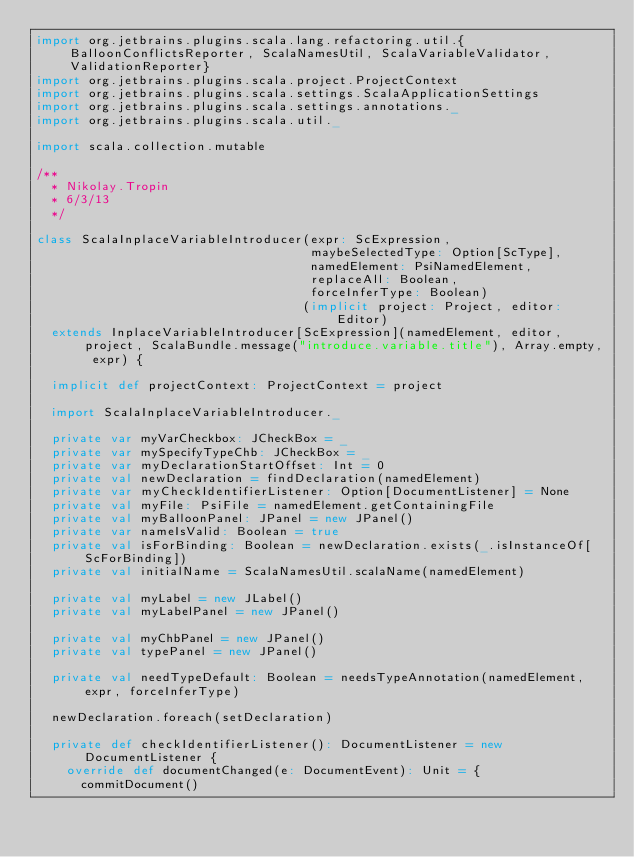Convert code to text. <code><loc_0><loc_0><loc_500><loc_500><_Scala_>import org.jetbrains.plugins.scala.lang.refactoring.util.{BalloonConflictsReporter, ScalaNamesUtil, ScalaVariableValidator, ValidationReporter}
import org.jetbrains.plugins.scala.project.ProjectContext
import org.jetbrains.plugins.scala.settings.ScalaApplicationSettings
import org.jetbrains.plugins.scala.settings.annotations._
import org.jetbrains.plugins.scala.util._

import scala.collection.mutable

/**
  * Nikolay.Tropin
  * 6/3/13
  */

class ScalaInplaceVariableIntroducer(expr: ScExpression,
                                     maybeSelectedType: Option[ScType],
                                     namedElement: PsiNamedElement,
                                     replaceAll: Boolean,
                                     forceInferType: Boolean)
                                    (implicit project: Project, editor: Editor)
  extends InplaceVariableIntroducer[ScExpression](namedElement, editor, project, ScalaBundle.message("introduce.variable.title"), Array.empty, expr) {

  implicit def projectContext: ProjectContext = project

  import ScalaInplaceVariableIntroducer._

  private var myVarCheckbox: JCheckBox = _
  private var mySpecifyTypeChb: JCheckBox = _
  private var myDeclarationStartOffset: Int = 0
  private val newDeclaration = findDeclaration(namedElement)
  private var myCheckIdentifierListener: Option[DocumentListener] = None
  private val myFile: PsiFile = namedElement.getContainingFile
  private val myBalloonPanel: JPanel = new JPanel()
  private var nameIsValid: Boolean = true
  private val isForBinding: Boolean = newDeclaration.exists(_.isInstanceOf[ScForBinding])
  private val initialName = ScalaNamesUtil.scalaName(namedElement)

  private val myLabel = new JLabel()
  private val myLabelPanel = new JPanel()

  private val myChbPanel = new JPanel()
  private val typePanel = new JPanel()

  private val needTypeDefault: Boolean = needsTypeAnnotation(namedElement, expr, forceInferType)

  newDeclaration.foreach(setDeclaration)

  private def checkIdentifierListener(): DocumentListener = new DocumentListener {
    override def documentChanged(e: DocumentEvent): Unit = {
      commitDocument()</code> 